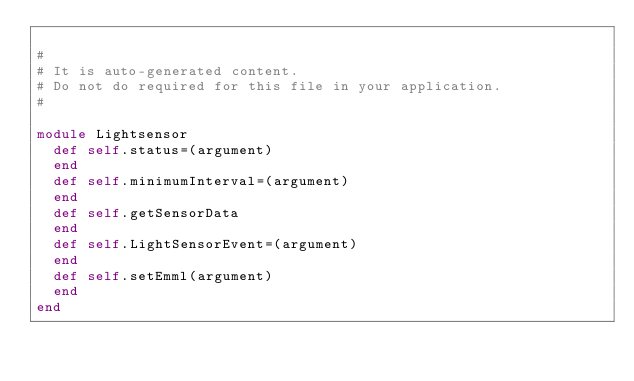<code> <loc_0><loc_0><loc_500><loc_500><_Ruby_> 
#
# It is auto-generated content.
# Do not do required for this file in your application.
#
 
module Lightsensor
  def self.status=(argument)
  end  
  def self.minimumInterval=(argument)
  end  
  def self.getSensorData
  end  
  def self.LightSensorEvent=(argument)
  end  
  def self.setEmml(argument)
  end  
end

</code> 